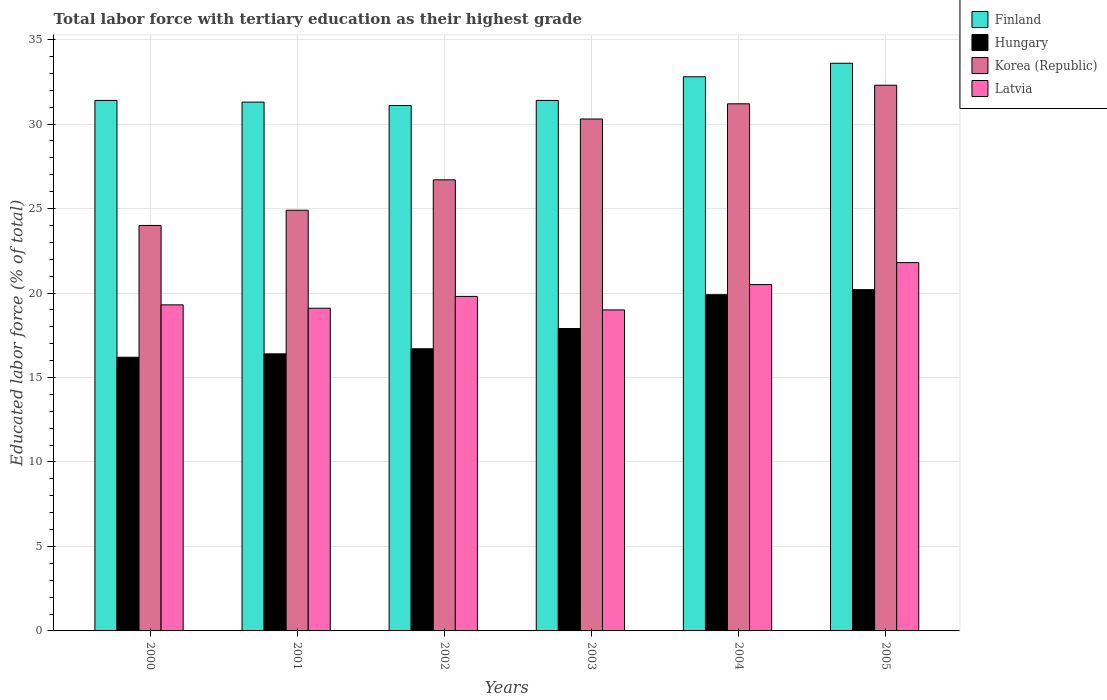How many different coloured bars are there?
Make the answer very short. 4. How many groups of bars are there?
Your answer should be very brief. 6. Are the number of bars on each tick of the X-axis equal?
Your answer should be very brief. Yes. How many bars are there on the 6th tick from the left?
Your answer should be compact. 4. How many bars are there on the 2nd tick from the right?
Ensure brevity in your answer.  4. What is the label of the 4th group of bars from the left?
Make the answer very short. 2003. Across all years, what is the maximum percentage of male labor force with tertiary education in Latvia?
Make the answer very short. 21.8. Across all years, what is the minimum percentage of male labor force with tertiary education in Latvia?
Keep it short and to the point. 19. What is the total percentage of male labor force with tertiary education in Korea (Republic) in the graph?
Your answer should be very brief. 169.4. What is the difference between the percentage of male labor force with tertiary education in Korea (Republic) in 2002 and that in 2003?
Provide a short and direct response. -3.6. What is the difference between the percentage of male labor force with tertiary education in Finland in 2000 and the percentage of male labor force with tertiary education in Korea (Republic) in 2002?
Offer a terse response. 4.7. What is the average percentage of male labor force with tertiary education in Hungary per year?
Offer a very short reply. 17.88. In the year 2001, what is the difference between the percentage of male labor force with tertiary education in Latvia and percentage of male labor force with tertiary education in Finland?
Provide a succinct answer. -12.2. What is the ratio of the percentage of male labor force with tertiary education in Korea (Republic) in 2001 to that in 2002?
Keep it short and to the point. 0.93. Is the percentage of male labor force with tertiary education in Latvia in 2002 less than that in 2004?
Keep it short and to the point. Yes. What is the difference between the highest and the second highest percentage of male labor force with tertiary education in Finland?
Your response must be concise. 0.8. What is the difference between the highest and the lowest percentage of male labor force with tertiary education in Finland?
Your answer should be very brief. 2.5. Is the sum of the percentage of male labor force with tertiary education in Finland in 2002 and 2004 greater than the maximum percentage of male labor force with tertiary education in Korea (Republic) across all years?
Make the answer very short. Yes. What does the 3rd bar from the right in 2000 represents?
Keep it short and to the point. Hungary. Is it the case that in every year, the sum of the percentage of male labor force with tertiary education in Hungary and percentage of male labor force with tertiary education in Finland is greater than the percentage of male labor force with tertiary education in Korea (Republic)?
Provide a short and direct response. Yes. How many years are there in the graph?
Your answer should be compact. 6. Does the graph contain any zero values?
Your answer should be very brief. No. Does the graph contain grids?
Your response must be concise. Yes. Where does the legend appear in the graph?
Give a very brief answer. Top right. What is the title of the graph?
Offer a very short reply. Total labor force with tertiary education as their highest grade. What is the label or title of the Y-axis?
Give a very brief answer. Educated labor force (% of total). What is the Educated labor force (% of total) in Finland in 2000?
Your answer should be very brief. 31.4. What is the Educated labor force (% of total) of Hungary in 2000?
Offer a terse response. 16.2. What is the Educated labor force (% of total) of Korea (Republic) in 2000?
Keep it short and to the point. 24. What is the Educated labor force (% of total) in Latvia in 2000?
Offer a very short reply. 19.3. What is the Educated labor force (% of total) in Finland in 2001?
Make the answer very short. 31.3. What is the Educated labor force (% of total) in Hungary in 2001?
Keep it short and to the point. 16.4. What is the Educated labor force (% of total) of Korea (Republic) in 2001?
Provide a short and direct response. 24.9. What is the Educated labor force (% of total) in Latvia in 2001?
Your response must be concise. 19.1. What is the Educated labor force (% of total) in Finland in 2002?
Make the answer very short. 31.1. What is the Educated labor force (% of total) of Hungary in 2002?
Provide a succinct answer. 16.7. What is the Educated labor force (% of total) of Korea (Republic) in 2002?
Offer a very short reply. 26.7. What is the Educated labor force (% of total) in Latvia in 2002?
Your answer should be compact. 19.8. What is the Educated labor force (% of total) in Finland in 2003?
Your response must be concise. 31.4. What is the Educated labor force (% of total) in Hungary in 2003?
Your answer should be compact. 17.9. What is the Educated labor force (% of total) of Korea (Republic) in 2003?
Provide a short and direct response. 30.3. What is the Educated labor force (% of total) of Latvia in 2003?
Offer a very short reply. 19. What is the Educated labor force (% of total) of Finland in 2004?
Your answer should be very brief. 32.8. What is the Educated labor force (% of total) of Hungary in 2004?
Your answer should be very brief. 19.9. What is the Educated labor force (% of total) of Korea (Republic) in 2004?
Offer a terse response. 31.2. What is the Educated labor force (% of total) of Latvia in 2004?
Provide a succinct answer. 20.5. What is the Educated labor force (% of total) of Finland in 2005?
Your response must be concise. 33.6. What is the Educated labor force (% of total) in Hungary in 2005?
Offer a terse response. 20.2. What is the Educated labor force (% of total) of Korea (Republic) in 2005?
Your answer should be compact. 32.3. What is the Educated labor force (% of total) of Latvia in 2005?
Provide a short and direct response. 21.8. Across all years, what is the maximum Educated labor force (% of total) in Finland?
Keep it short and to the point. 33.6. Across all years, what is the maximum Educated labor force (% of total) in Hungary?
Your response must be concise. 20.2. Across all years, what is the maximum Educated labor force (% of total) of Korea (Republic)?
Give a very brief answer. 32.3. Across all years, what is the maximum Educated labor force (% of total) in Latvia?
Make the answer very short. 21.8. Across all years, what is the minimum Educated labor force (% of total) of Finland?
Your answer should be compact. 31.1. Across all years, what is the minimum Educated labor force (% of total) in Hungary?
Your answer should be compact. 16.2. Across all years, what is the minimum Educated labor force (% of total) in Latvia?
Ensure brevity in your answer.  19. What is the total Educated labor force (% of total) in Finland in the graph?
Your answer should be very brief. 191.6. What is the total Educated labor force (% of total) in Hungary in the graph?
Provide a short and direct response. 107.3. What is the total Educated labor force (% of total) of Korea (Republic) in the graph?
Give a very brief answer. 169.4. What is the total Educated labor force (% of total) of Latvia in the graph?
Offer a terse response. 119.5. What is the difference between the Educated labor force (% of total) in Hungary in 2000 and that in 2001?
Give a very brief answer. -0.2. What is the difference between the Educated labor force (% of total) of Korea (Republic) in 2000 and that in 2001?
Keep it short and to the point. -0.9. What is the difference between the Educated labor force (% of total) of Latvia in 2000 and that in 2001?
Your response must be concise. 0.2. What is the difference between the Educated labor force (% of total) in Finland in 2000 and that in 2002?
Keep it short and to the point. 0.3. What is the difference between the Educated labor force (% of total) in Hungary in 2000 and that in 2002?
Ensure brevity in your answer.  -0.5. What is the difference between the Educated labor force (% of total) of Hungary in 2000 and that in 2003?
Provide a succinct answer. -1.7. What is the difference between the Educated labor force (% of total) in Korea (Republic) in 2000 and that in 2003?
Make the answer very short. -6.3. What is the difference between the Educated labor force (% of total) of Hungary in 2000 and that in 2004?
Offer a very short reply. -3.7. What is the difference between the Educated labor force (% of total) in Latvia in 2000 and that in 2004?
Provide a succinct answer. -1.2. What is the difference between the Educated labor force (% of total) in Latvia in 2000 and that in 2005?
Ensure brevity in your answer.  -2.5. What is the difference between the Educated labor force (% of total) of Finland in 2001 and that in 2002?
Provide a short and direct response. 0.2. What is the difference between the Educated labor force (% of total) in Latvia in 2001 and that in 2002?
Ensure brevity in your answer.  -0.7. What is the difference between the Educated labor force (% of total) in Korea (Republic) in 2001 and that in 2003?
Provide a short and direct response. -5.4. What is the difference between the Educated labor force (% of total) in Finland in 2001 and that in 2004?
Give a very brief answer. -1.5. What is the difference between the Educated labor force (% of total) in Hungary in 2001 and that in 2004?
Provide a short and direct response. -3.5. What is the difference between the Educated labor force (% of total) of Korea (Republic) in 2001 and that in 2004?
Ensure brevity in your answer.  -6.3. What is the difference between the Educated labor force (% of total) in Finland in 2001 and that in 2005?
Keep it short and to the point. -2.3. What is the difference between the Educated labor force (% of total) of Hungary in 2001 and that in 2005?
Provide a short and direct response. -3.8. What is the difference between the Educated labor force (% of total) of Korea (Republic) in 2001 and that in 2005?
Your response must be concise. -7.4. What is the difference between the Educated labor force (% of total) in Latvia in 2001 and that in 2005?
Ensure brevity in your answer.  -2.7. What is the difference between the Educated labor force (% of total) in Hungary in 2002 and that in 2003?
Make the answer very short. -1.2. What is the difference between the Educated labor force (% of total) of Finland in 2002 and that in 2004?
Provide a succinct answer. -1.7. What is the difference between the Educated labor force (% of total) of Latvia in 2002 and that in 2004?
Offer a terse response. -0.7. What is the difference between the Educated labor force (% of total) in Finland in 2002 and that in 2005?
Offer a very short reply. -2.5. What is the difference between the Educated labor force (% of total) in Korea (Republic) in 2002 and that in 2005?
Ensure brevity in your answer.  -5.6. What is the difference between the Educated labor force (% of total) of Latvia in 2002 and that in 2005?
Give a very brief answer. -2. What is the difference between the Educated labor force (% of total) of Finland in 2003 and that in 2004?
Make the answer very short. -1.4. What is the difference between the Educated labor force (% of total) in Hungary in 2003 and that in 2004?
Offer a very short reply. -2. What is the difference between the Educated labor force (% of total) of Latvia in 2003 and that in 2004?
Offer a terse response. -1.5. What is the difference between the Educated labor force (% of total) of Korea (Republic) in 2003 and that in 2005?
Your response must be concise. -2. What is the difference between the Educated labor force (% of total) of Latvia in 2003 and that in 2005?
Offer a very short reply. -2.8. What is the difference between the Educated labor force (% of total) in Finland in 2004 and that in 2005?
Give a very brief answer. -0.8. What is the difference between the Educated labor force (% of total) in Hungary in 2004 and that in 2005?
Make the answer very short. -0.3. What is the difference between the Educated labor force (% of total) in Finland in 2000 and the Educated labor force (% of total) in Hungary in 2001?
Your answer should be very brief. 15. What is the difference between the Educated labor force (% of total) of Finland in 2000 and the Educated labor force (% of total) of Korea (Republic) in 2001?
Provide a short and direct response. 6.5. What is the difference between the Educated labor force (% of total) of Hungary in 2000 and the Educated labor force (% of total) of Korea (Republic) in 2001?
Make the answer very short. -8.7. What is the difference between the Educated labor force (% of total) in Hungary in 2000 and the Educated labor force (% of total) in Latvia in 2001?
Ensure brevity in your answer.  -2.9. What is the difference between the Educated labor force (% of total) of Finland in 2000 and the Educated labor force (% of total) of Hungary in 2002?
Give a very brief answer. 14.7. What is the difference between the Educated labor force (% of total) in Finland in 2000 and the Educated labor force (% of total) in Korea (Republic) in 2002?
Give a very brief answer. 4.7. What is the difference between the Educated labor force (% of total) in Hungary in 2000 and the Educated labor force (% of total) in Korea (Republic) in 2002?
Make the answer very short. -10.5. What is the difference between the Educated labor force (% of total) in Hungary in 2000 and the Educated labor force (% of total) in Latvia in 2002?
Ensure brevity in your answer.  -3.6. What is the difference between the Educated labor force (% of total) in Finland in 2000 and the Educated labor force (% of total) in Latvia in 2003?
Ensure brevity in your answer.  12.4. What is the difference between the Educated labor force (% of total) of Hungary in 2000 and the Educated labor force (% of total) of Korea (Republic) in 2003?
Keep it short and to the point. -14.1. What is the difference between the Educated labor force (% of total) of Hungary in 2000 and the Educated labor force (% of total) of Latvia in 2003?
Keep it short and to the point. -2.8. What is the difference between the Educated labor force (% of total) of Finland in 2000 and the Educated labor force (% of total) of Hungary in 2004?
Your response must be concise. 11.5. What is the difference between the Educated labor force (% of total) of Hungary in 2000 and the Educated labor force (% of total) of Korea (Republic) in 2004?
Offer a terse response. -15. What is the difference between the Educated labor force (% of total) of Korea (Republic) in 2000 and the Educated labor force (% of total) of Latvia in 2004?
Provide a short and direct response. 3.5. What is the difference between the Educated labor force (% of total) of Finland in 2000 and the Educated labor force (% of total) of Latvia in 2005?
Offer a very short reply. 9.6. What is the difference between the Educated labor force (% of total) in Hungary in 2000 and the Educated labor force (% of total) in Korea (Republic) in 2005?
Offer a very short reply. -16.1. What is the difference between the Educated labor force (% of total) of Finland in 2001 and the Educated labor force (% of total) of Latvia in 2002?
Your response must be concise. 11.5. What is the difference between the Educated labor force (% of total) in Korea (Republic) in 2001 and the Educated labor force (% of total) in Latvia in 2002?
Your response must be concise. 5.1. What is the difference between the Educated labor force (% of total) in Finland in 2001 and the Educated labor force (% of total) in Hungary in 2003?
Provide a short and direct response. 13.4. What is the difference between the Educated labor force (% of total) of Finland in 2001 and the Educated labor force (% of total) of Korea (Republic) in 2003?
Your answer should be very brief. 1. What is the difference between the Educated labor force (% of total) of Hungary in 2001 and the Educated labor force (% of total) of Latvia in 2003?
Your answer should be very brief. -2.6. What is the difference between the Educated labor force (% of total) of Finland in 2001 and the Educated labor force (% of total) of Latvia in 2004?
Offer a terse response. 10.8. What is the difference between the Educated labor force (% of total) in Hungary in 2001 and the Educated labor force (% of total) in Korea (Republic) in 2004?
Give a very brief answer. -14.8. What is the difference between the Educated labor force (% of total) in Hungary in 2001 and the Educated labor force (% of total) in Latvia in 2004?
Make the answer very short. -4.1. What is the difference between the Educated labor force (% of total) of Finland in 2001 and the Educated labor force (% of total) of Latvia in 2005?
Ensure brevity in your answer.  9.5. What is the difference between the Educated labor force (% of total) in Hungary in 2001 and the Educated labor force (% of total) in Korea (Republic) in 2005?
Ensure brevity in your answer.  -15.9. What is the difference between the Educated labor force (% of total) in Finland in 2002 and the Educated labor force (% of total) in Hungary in 2003?
Your answer should be very brief. 13.2. What is the difference between the Educated labor force (% of total) in Finland in 2002 and the Educated labor force (% of total) in Korea (Republic) in 2003?
Make the answer very short. 0.8. What is the difference between the Educated labor force (% of total) of Hungary in 2002 and the Educated labor force (% of total) of Korea (Republic) in 2003?
Offer a terse response. -13.6. What is the difference between the Educated labor force (% of total) of Hungary in 2002 and the Educated labor force (% of total) of Latvia in 2003?
Make the answer very short. -2.3. What is the difference between the Educated labor force (% of total) of Korea (Republic) in 2002 and the Educated labor force (% of total) of Latvia in 2003?
Offer a terse response. 7.7. What is the difference between the Educated labor force (% of total) in Finland in 2002 and the Educated labor force (% of total) in Hungary in 2004?
Offer a terse response. 11.2. What is the difference between the Educated labor force (% of total) of Finland in 2002 and the Educated labor force (% of total) of Korea (Republic) in 2004?
Your response must be concise. -0.1. What is the difference between the Educated labor force (% of total) in Finland in 2002 and the Educated labor force (% of total) in Latvia in 2004?
Provide a short and direct response. 10.6. What is the difference between the Educated labor force (% of total) of Hungary in 2002 and the Educated labor force (% of total) of Korea (Republic) in 2004?
Give a very brief answer. -14.5. What is the difference between the Educated labor force (% of total) in Hungary in 2002 and the Educated labor force (% of total) in Latvia in 2004?
Give a very brief answer. -3.8. What is the difference between the Educated labor force (% of total) in Korea (Republic) in 2002 and the Educated labor force (% of total) in Latvia in 2004?
Offer a terse response. 6.2. What is the difference between the Educated labor force (% of total) of Hungary in 2002 and the Educated labor force (% of total) of Korea (Republic) in 2005?
Your response must be concise. -15.6. What is the difference between the Educated labor force (% of total) of Hungary in 2002 and the Educated labor force (% of total) of Latvia in 2005?
Your answer should be compact. -5.1. What is the difference between the Educated labor force (% of total) of Finland in 2003 and the Educated labor force (% of total) of Latvia in 2004?
Your answer should be very brief. 10.9. What is the difference between the Educated labor force (% of total) in Hungary in 2003 and the Educated labor force (% of total) in Latvia in 2004?
Give a very brief answer. -2.6. What is the difference between the Educated labor force (% of total) of Korea (Republic) in 2003 and the Educated labor force (% of total) of Latvia in 2004?
Ensure brevity in your answer.  9.8. What is the difference between the Educated labor force (% of total) in Hungary in 2003 and the Educated labor force (% of total) in Korea (Republic) in 2005?
Ensure brevity in your answer.  -14.4. What is the difference between the Educated labor force (% of total) in Hungary in 2003 and the Educated labor force (% of total) in Latvia in 2005?
Provide a succinct answer. -3.9. What is the difference between the Educated labor force (% of total) of Korea (Republic) in 2003 and the Educated labor force (% of total) of Latvia in 2005?
Offer a terse response. 8.5. What is the difference between the Educated labor force (% of total) of Finland in 2004 and the Educated labor force (% of total) of Korea (Republic) in 2005?
Offer a terse response. 0.5. What is the difference between the Educated labor force (% of total) in Hungary in 2004 and the Educated labor force (% of total) in Korea (Republic) in 2005?
Your answer should be very brief. -12.4. What is the difference between the Educated labor force (% of total) of Hungary in 2004 and the Educated labor force (% of total) of Latvia in 2005?
Your answer should be compact. -1.9. What is the difference between the Educated labor force (% of total) of Korea (Republic) in 2004 and the Educated labor force (% of total) of Latvia in 2005?
Keep it short and to the point. 9.4. What is the average Educated labor force (% of total) of Finland per year?
Keep it short and to the point. 31.93. What is the average Educated labor force (% of total) of Hungary per year?
Give a very brief answer. 17.88. What is the average Educated labor force (% of total) in Korea (Republic) per year?
Your response must be concise. 28.23. What is the average Educated labor force (% of total) in Latvia per year?
Your answer should be very brief. 19.92. In the year 2000, what is the difference between the Educated labor force (% of total) in Hungary and Educated labor force (% of total) in Latvia?
Keep it short and to the point. -3.1. In the year 2000, what is the difference between the Educated labor force (% of total) of Korea (Republic) and Educated labor force (% of total) of Latvia?
Make the answer very short. 4.7. In the year 2001, what is the difference between the Educated labor force (% of total) of Finland and Educated labor force (% of total) of Hungary?
Offer a very short reply. 14.9. In the year 2001, what is the difference between the Educated labor force (% of total) in Finland and Educated labor force (% of total) in Korea (Republic)?
Keep it short and to the point. 6.4. In the year 2001, what is the difference between the Educated labor force (% of total) of Finland and Educated labor force (% of total) of Latvia?
Offer a terse response. 12.2. In the year 2001, what is the difference between the Educated labor force (% of total) in Hungary and Educated labor force (% of total) in Latvia?
Make the answer very short. -2.7. In the year 2001, what is the difference between the Educated labor force (% of total) in Korea (Republic) and Educated labor force (% of total) in Latvia?
Provide a short and direct response. 5.8. In the year 2002, what is the difference between the Educated labor force (% of total) of Finland and Educated labor force (% of total) of Korea (Republic)?
Offer a very short reply. 4.4. In the year 2002, what is the difference between the Educated labor force (% of total) of Finland and Educated labor force (% of total) of Latvia?
Your answer should be compact. 11.3. In the year 2002, what is the difference between the Educated labor force (% of total) of Hungary and Educated labor force (% of total) of Latvia?
Keep it short and to the point. -3.1. In the year 2002, what is the difference between the Educated labor force (% of total) of Korea (Republic) and Educated labor force (% of total) of Latvia?
Make the answer very short. 6.9. In the year 2003, what is the difference between the Educated labor force (% of total) of Finland and Educated labor force (% of total) of Korea (Republic)?
Give a very brief answer. 1.1. In the year 2003, what is the difference between the Educated labor force (% of total) in Korea (Republic) and Educated labor force (% of total) in Latvia?
Provide a short and direct response. 11.3. In the year 2004, what is the difference between the Educated labor force (% of total) in Finland and Educated labor force (% of total) in Hungary?
Offer a very short reply. 12.9. In the year 2004, what is the difference between the Educated labor force (% of total) of Finland and Educated labor force (% of total) of Korea (Republic)?
Provide a succinct answer. 1.6. In the year 2004, what is the difference between the Educated labor force (% of total) in Finland and Educated labor force (% of total) in Latvia?
Your answer should be compact. 12.3. In the year 2004, what is the difference between the Educated labor force (% of total) of Hungary and Educated labor force (% of total) of Korea (Republic)?
Your answer should be very brief. -11.3. In the year 2004, what is the difference between the Educated labor force (% of total) of Hungary and Educated labor force (% of total) of Latvia?
Provide a short and direct response. -0.6. In the year 2005, what is the difference between the Educated labor force (% of total) in Finland and Educated labor force (% of total) in Hungary?
Ensure brevity in your answer.  13.4. In the year 2005, what is the difference between the Educated labor force (% of total) of Hungary and Educated labor force (% of total) of Korea (Republic)?
Ensure brevity in your answer.  -12.1. In the year 2005, what is the difference between the Educated labor force (% of total) in Hungary and Educated labor force (% of total) in Latvia?
Provide a short and direct response. -1.6. In the year 2005, what is the difference between the Educated labor force (% of total) in Korea (Republic) and Educated labor force (% of total) in Latvia?
Ensure brevity in your answer.  10.5. What is the ratio of the Educated labor force (% of total) of Finland in 2000 to that in 2001?
Your answer should be very brief. 1. What is the ratio of the Educated labor force (% of total) in Korea (Republic) in 2000 to that in 2001?
Make the answer very short. 0.96. What is the ratio of the Educated labor force (% of total) in Latvia in 2000 to that in 2001?
Offer a terse response. 1.01. What is the ratio of the Educated labor force (% of total) in Finland in 2000 to that in 2002?
Ensure brevity in your answer.  1.01. What is the ratio of the Educated labor force (% of total) in Hungary in 2000 to that in 2002?
Offer a terse response. 0.97. What is the ratio of the Educated labor force (% of total) of Korea (Republic) in 2000 to that in 2002?
Provide a succinct answer. 0.9. What is the ratio of the Educated labor force (% of total) in Latvia in 2000 to that in 2002?
Your answer should be very brief. 0.97. What is the ratio of the Educated labor force (% of total) of Finland in 2000 to that in 2003?
Your answer should be compact. 1. What is the ratio of the Educated labor force (% of total) in Hungary in 2000 to that in 2003?
Keep it short and to the point. 0.91. What is the ratio of the Educated labor force (% of total) in Korea (Republic) in 2000 to that in 2003?
Provide a succinct answer. 0.79. What is the ratio of the Educated labor force (% of total) in Latvia in 2000 to that in 2003?
Give a very brief answer. 1.02. What is the ratio of the Educated labor force (% of total) in Finland in 2000 to that in 2004?
Ensure brevity in your answer.  0.96. What is the ratio of the Educated labor force (% of total) in Hungary in 2000 to that in 2004?
Offer a terse response. 0.81. What is the ratio of the Educated labor force (% of total) in Korea (Republic) in 2000 to that in 2004?
Your answer should be compact. 0.77. What is the ratio of the Educated labor force (% of total) in Latvia in 2000 to that in 2004?
Your answer should be compact. 0.94. What is the ratio of the Educated labor force (% of total) of Finland in 2000 to that in 2005?
Provide a succinct answer. 0.93. What is the ratio of the Educated labor force (% of total) of Hungary in 2000 to that in 2005?
Offer a terse response. 0.8. What is the ratio of the Educated labor force (% of total) of Korea (Republic) in 2000 to that in 2005?
Offer a very short reply. 0.74. What is the ratio of the Educated labor force (% of total) of Latvia in 2000 to that in 2005?
Your answer should be compact. 0.89. What is the ratio of the Educated labor force (% of total) in Finland in 2001 to that in 2002?
Provide a succinct answer. 1.01. What is the ratio of the Educated labor force (% of total) in Korea (Republic) in 2001 to that in 2002?
Your answer should be very brief. 0.93. What is the ratio of the Educated labor force (% of total) in Latvia in 2001 to that in 2002?
Your answer should be compact. 0.96. What is the ratio of the Educated labor force (% of total) of Finland in 2001 to that in 2003?
Make the answer very short. 1. What is the ratio of the Educated labor force (% of total) of Hungary in 2001 to that in 2003?
Your response must be concise. 0.92. What is the ratio of the Educated labor force (% of total) of Korea (Republic) in 2001 to that in 2003?
Make the answer very short. 0.82. What is the ratio of the Educated labor force (% of total) in Finland in 2001 to that in 2004?
Your answer should be very brief. 0.95. What is the ratio of the Educated labor force (% of total) in Hungary in 2001 to that in 2004?
Offer a very short reply. 0.82. What is the ratio of the Educated labor force (% of total) in Korea (Republic) in 2001 to that in 2004?
Offer a terse response. 0.8. What is the ratio of the Educated labor force (% of total) of Latvia in 2001 to that in 2004?
Your response must be concise. 0.93. What is the ratio of the Educated labor force (% of total) in Finland in 2001 to that in 2005?
Keep it short and to the point. 0.93. What is the ratio of the Educated labor force (% of total) in Hungary in 2001 to that in 2005?
Give a very brief answer. 0.81. What is the ratio of the Educated labor force (% of total) in Korea (Republic) in 2001 to that in 2005?
Provide a short and direct response. 0.77. What is the ratio of the Educated labor force (% of total) in Latvia in 2001 to that in 2005?
Offer a terse response. 0.88. What is the ratio of the Educated labor force (% of total) in Hungary in 2002 to that in 2003?
Make the answer very short. 0.93. What is the ratio of the Educated labor force (% of total) of Korea (Republic) in 2002 to that in 2003?
Provide a short and direct response. 0.88. What is the ratio of the Educated labor force (% of total) in Latvia in 2002 to that in 2003?
Provide a short and direct response. 1.04. What is the ratio of the Educated labor force (% of total) in Finland in 2002 to that in 2004?
Provide a short and direct response. 0.95. What is the ratio of the Educated labor force (% of total) of Hungary in 2002 to that in 2004?
Offer a very short reply. 0.84. What is the ratio of the Educated labor force (% of total) of Korea (Republic) in 2002 to that in 2004?
Your answer should be compact. 0.86. What is the ratio of the Educated labor force (% of total) of Latvia in 2002 to that in 2004?
Provide a succinct answer. 0.97. What is the ratio of the Educated labor force (% of total) of Finland in 2002 to that in 2005?
Keep it short and to the point. 0.93. What is the ratio of the Educated labor force (% of total) of Hungary in 2002 to that in 2005?
Your response must be concise. 0.83. What is the ratio of the Educated labor force (% of total) of Korea (Republic) in 2002 to that in 2005?
Your answer should be very brief. 0.83. What is the ratio of the Educated labor force (% of total) of Latvia in 2002 to that in 2005?
Offer a terse response. 0.91. What is the ratio of the Educated labor force (% of total) in Finland in 2003 to that in 2004?
Make the answer very short. 0.96. What is the ratio of the Educated labor force (% of total) of Hungary in 2003 to that in 2004?
Provide a succinct answer. 0.9. What is the ratio of the Educated labor force (% of total) in Korea (Republic) in 2003 to that in 2004?
Keep it short and to the point. 0.97. What is the ratio of the Educated labor force (% of total) in Latvia in 2003 to that in 2004?
Give a very brief answer. 0.93. What is the ratio of the Educated labor force (% of total) in Finland in 2003 to that in 2005?
Your answer should be compact. 0.93. What is the ratio of the Educated labor force (% of total) in Hungary in 2003 to that in 2005?
Your response must be concise. 0.89. What is the ratio of the Educated labor force (% of total) of Korea (Republic) in 2003 to that in 2005?
Your answer should be very brief. 0.94. What is the ratio of the Educated labor force (% of total) of Latvia in 2003 to that in 2005?
Your answer should be very brief. 0.87. What is the ratio of the Educated labor force (% of total) of Finland in 2004 to that in 2005?
Offer a terse response. 0.98. What is the ratio of the Educated labor force (% of total) in Hungary in 2004 to that in 2005?
Your response must be concise. 0.99. What is the ratio of the Educated labor force (% of total) in Korea (Republic) in 2004 to that in 2005?
Offer a very short reply. 0.97. What is the ratio of the Educated labor force (% of total) in Latvia in 2004 to that in 2005?
Make the answer very short. 0.94. What is the difference between the highest and the second highest Educated labor force (% of total) of Finland?
Your response must be concise. 0.8. What is the difference between the highest and the lowest Educated labor force (% of total) of Korea (Republic)?
Your answer should be very brief. 8.3. What is the difference between the highest and the lowest Educated labor force (% of total) of Latvia?
Your answer should be very brief. 2.8. 